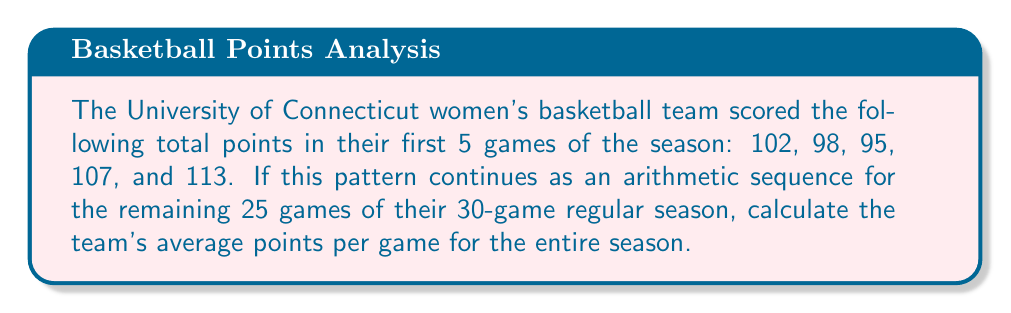Could you help me with this problem? Let's approach this step-by-step:

1) First, we need to determine if the given scores form an arithmetic sequence and find the common difference:
   $98 - 102 = -4$
   $95 - 98 = -3$
   $107 - 95 = 12$
   $113 - 107 = 6$
   
   The differences are not constant, so this is not an arithmetic sequence.

2) However, the question states that the pattern continues as an arithmetic sequence for the remaining games. We need to find the common difference using the last two given scores:
   $d = 113 - 107 = 6$

3) Now we can calculate the sum of the first 5 games:
   $S_5 = 102 + 98 + 95 + 107 + 113 = 515$

4) For the remaining 25 games, we have an arithmetic sequence with:
   $a_1 = 113$ (the last given score)
   $d = 6$
   $n = 25$

5) The sum of an arithmetic sequence is given by:
   $S_n = \frac{n}{2}(a_1 + a_n)$, where $a_n = a_1 + (n-1)d$

6) Calculate $a_{25}$:
   $a_{25} = 113 + (25-1)6 = 113 + 144 = 257$

7) Now calculate the sum of the remaining 25 games:
   $S_{25} = \frac{25}{2}(113 + 257) = \frac{25}{2}(370) = 4625$

8) Total points for all 30 games:
   $515 + 4625 = 5140$

9) Average points per game:
   $\frac{5140}{30} = 171.33333...$
Answer: $171\frac{1}{3}$ points per game 